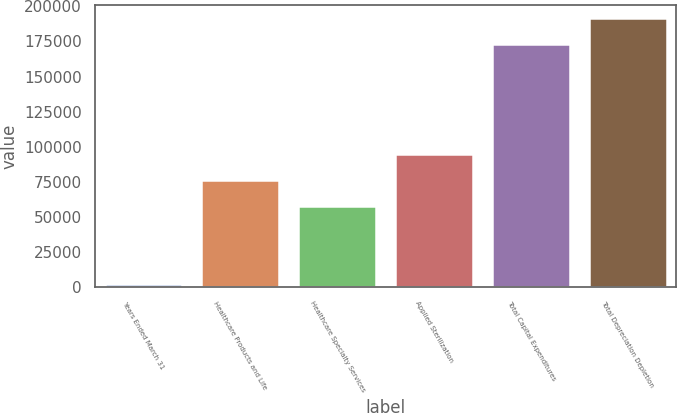Convert chart to OTSL. <chart><loc_0><loc_0><loc_500><loc_500><bar_chart><fcel>Years Ended March 31<fcel>Healthcare Products and Life<fcel>Healthcare Specialty Services<fcel>Applied Sterilization<fcel>Total Capital Expenditures<fcel>Total Depreciation Depletion<nl><fcel>2017<fcel>76478<fcel>57865.5<fcel>95090.5<fcel>172901<fcel>191514<nl></chart> 